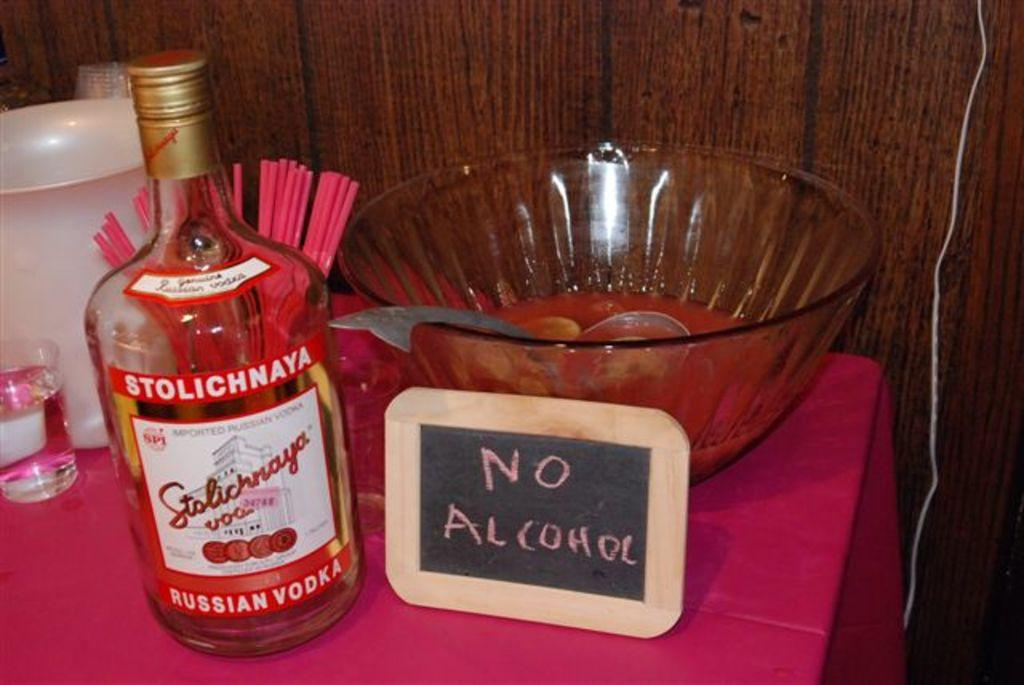Provide a one-sentence caption for the provided image. A bottle of Russian vodka next to a sign that says no alcohol. 